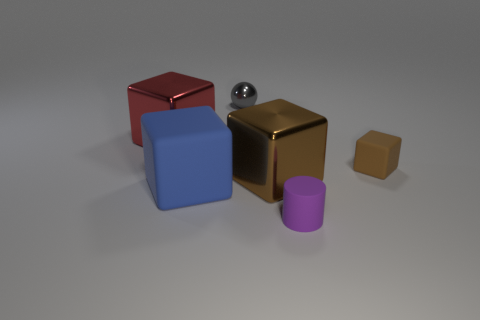Is there a big rubber thing that has the same color as the small metal thing?
Offer a terse response. No. Do the metal thing that is to the right of the shiny ball and the brown matte cube have the same size?
Keep it short and to the point. No. Are there the same number of tiny blocks that are behind the large red block and big cubes?
Offer a very short reply. No. What number of things are tiny objects to the left of the purple rubber thing or gray balls?
Your response must be concise. 1. What is the shape of the metal thing that is behind the brown metallic thing and on the right side of the big blue object?
Your answer should be very brief. Sphere. What number of things are either large things that are to the right of the small sphere or large blocks right of the large red block?
Your response must be concise. 2. How many other objects are the same size as the blue object?
Your answer should be compact. 2. There is a large shiny block behind the big brown metal object; does it have the same color as the metallic sphere?
Your response must be concise. No. There is a shiny thing that is on the right side of the big red cube and in front of the gray sphere; what size is it?
Provide a short and direct response. Large. How many large things are gray objects or purple cylinders?
Your response must be concise. 0. 